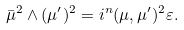Convert formula to latex. <formula><loc_0><loc_0><loc_500><loc_500>\bar { \mu } ^ { 2 } \wedge ( \mu ^ { \prime } ) ^ { 2 } = i ^ { n } ( \mu , \mu ^ { \prime } ) ^ { 2 } \varepsilon .</formula> 